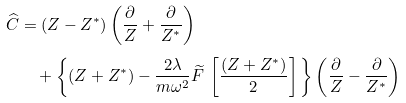<formula> <loc_0><loc_0><loc_500><loc_500>\widehat { C } & = ( Z - Z ^ { * } ) \left ( \frac { \partial } { Z } + \frac { \partial } { Z ^ { * } } \right ) \\ & \quad + \left \{ ( Z + Z ^ { * } ) - \frac { 2 \lambda } { m \omega ^ { 2 } } \widetilde { F } \, \left [ \frac { ( Z + Z ^ { * } ) } { 2 } \right ] \Big . \right \} \left ( \frac { \partial } { Z } - \frac { \partial } { Z ^ { * } } \right )</formula> 